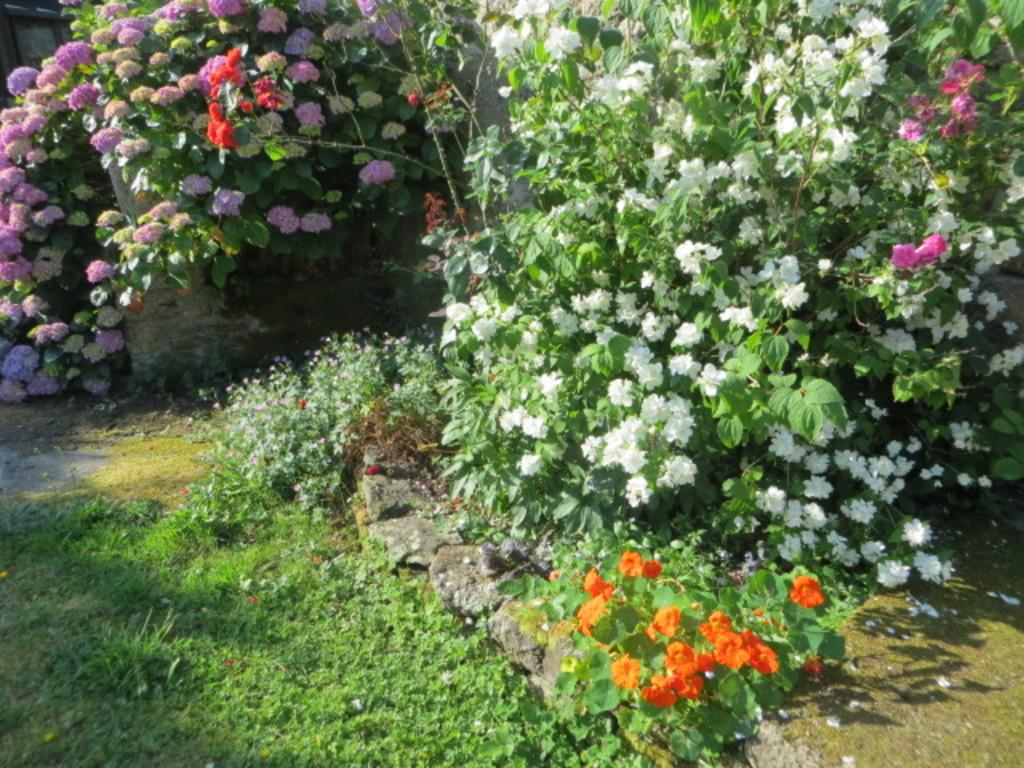What type of vegetation is present in the image? There are flower plants and grass in the image. What else can be seen in the image besides vegetation? There are rocks in the image. Who created the rocks in the image? The image does not provide information about the creator of the rocks, as they are natural elements. 